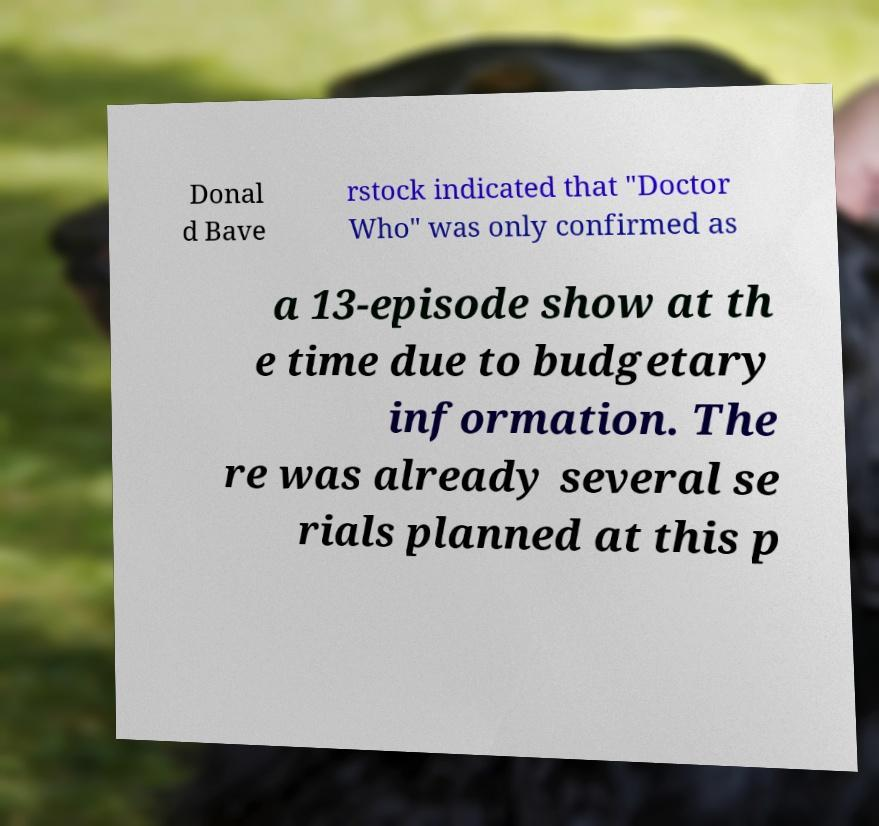Could you assist in decoding the text presented in this image and type it out clearly? Donal d Bave rstock indicated that "Doctor Who" was only confirmed as a 13-episode show at th e time due to budgetary information. The re was already several se rials planned at this p 